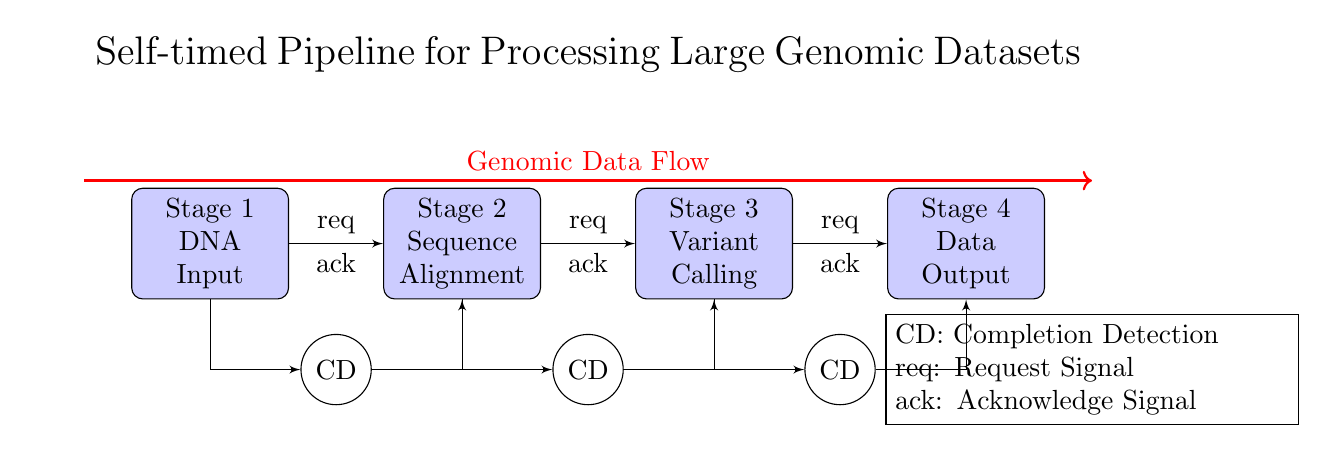What is the input for Stage 1? The input for Stage 1 is "DNA Input," which is indicated in the block labeled Stage 1.
Answer: DNA Input What type of signals are used for communication between stages? The communication between stages is facilitated by "request" and "acknowledge" signals, as labeled on the connecting lines between the blocks.
Answer: request and acknowledge signals How many stages are there in this pipeline? There are four stages depicted in the circuit diagram, which can be counted from the labeled blocks.
Answer: 4 Which stage is responsible for "Variant Calling"? The "Variant Calling" is handled by Stage 3, as specified in the label of the corresponding block in the diagram.
Answer: Stage 3 What role does Completion Detection play in the pipeline? Completion Detection (CD) indicates when each stage has finished processing before allowing the next stage to begin, as inferred from its connections and placement in the circuit.
Answer: Indicate processing completion Explain the direction of the data flow in the circuit. The data flow is represented by a thick red arrow that shows the path of "Genomic Data Flow" moving from the left side of the diagram to the right, passing through all the stages.
Answer: Left to right What does 'CD' stand for in this circuit? 'CD' stands for "Completion Detection," as defined in the legend provided at the bottom of the circuit diagram.
Answer: Completion Detection 